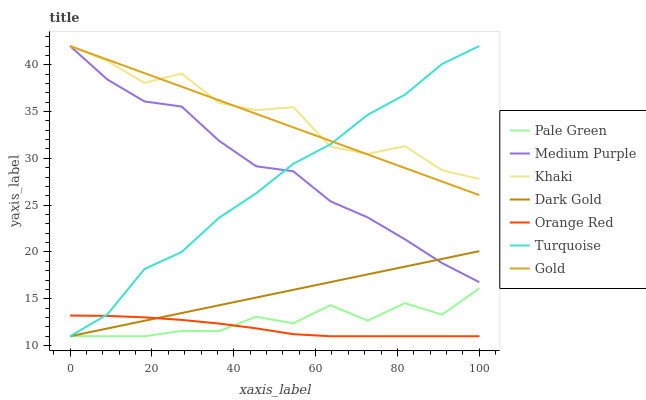Does Orange Red have the minimum area under the curve?
Answer yes or no. Yes. Does Khaki have the maximum area under the curve?
Answer yes or no. Yes. Does Gold have the minimum area under the curve?
Answer yes or no. No. Does Gold have the maximum area under the curve?
Answer yes or no. No. Is Gold the smoothest?
Answer yes or no. Yes. Is Khaki the roughest?
Answer yes or no. Yes. Is Khaki the smoothest?
Answer yes or no. No. Is Gold the roughest?
Answer yes or no. No. Does Gold have the lowest value?
Answer yes or no. No. Does Dark Gold have the highest value?
Answer yes or no. No. Is Orange Red less than Gold?
Answer yes or no. Yes. Is Gold greater than Dark Gold?
Answer yes or no. Yes. Does Orange Red intersect Gold?
Answer yes or no. No. 